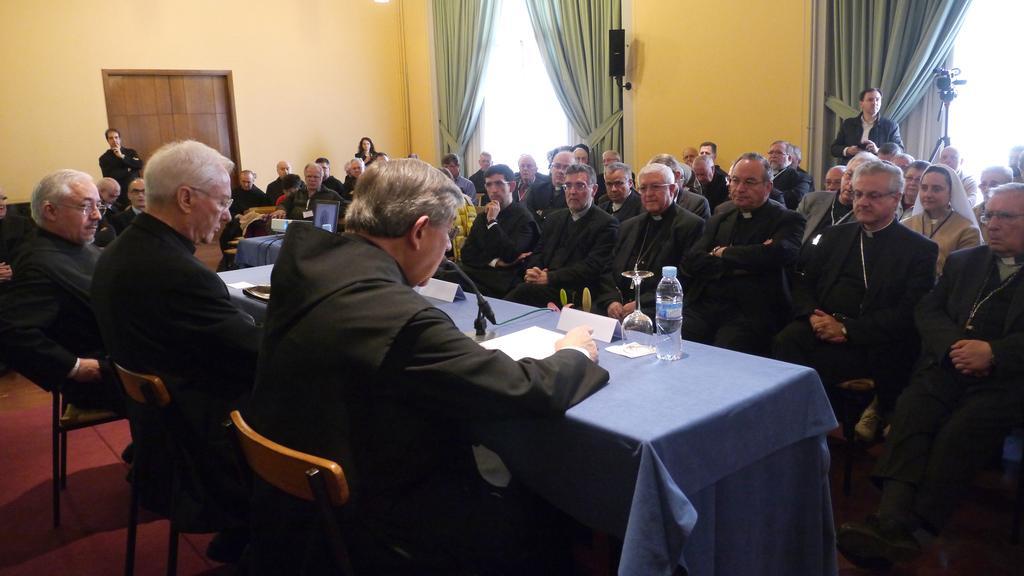Please provide a concise description of this image. There are groups of people sitting on the chairs. This is the table, which is covered with the cloth. I can see a wine glass, name boards, mike, papers and water bottle are placed on the table. I can see the curtains hanging. This looks like a video recorder with the tripod stand. I can see three people standing. This looks like a door. I think these are the windows. 